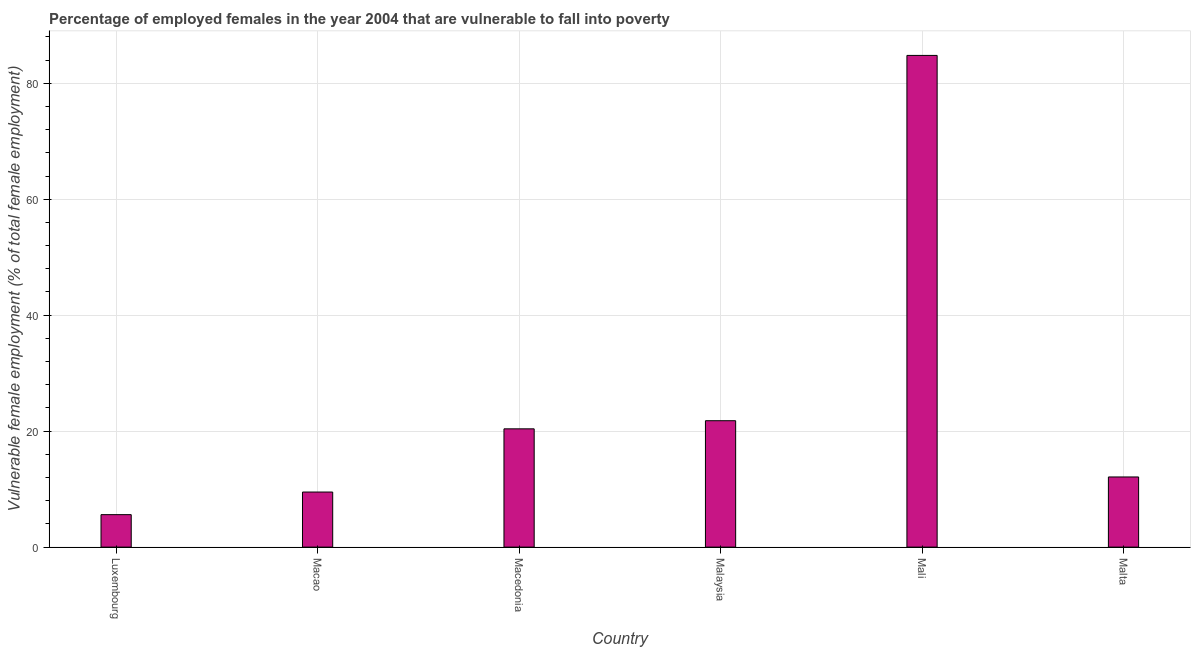Does the graph contain any zero values?
Your response must be concise. No. Does the graph contain grids?
Provide a succinct answer. Yes. What is the title of the graph?
Make the answer very short. Percentage of employed females in the year 2004 that are vulnerable to fall into poverty. What is the label or title of the Y-axis?
Offer a very short reply. Vulnerable female employment (% of total female employment). What is the percentage of employed females who are vulnerable to fall into poverty in Malaysia?
Your answer should be compact. 21.8. Across all countries, what is the maximum percentage of employed females who are vulnerable to fall into poverty?
Offer a very short reply. 84.8. Across all countries, what is the minimum percentage of employed females who are vulnerable to fall into poverty?
Your answer should be compact. 5.6. In which country was the percentage of employed females who are vulnerable to fall into poverty maximum?
Make the answer very short. Mali. In which country was the percentage of employed females who are vulnerable to fall into poverty minimum?
Offer a terse response. Luxembourg. What is the sum of the percentage of employed females who are vulnerable to fall into poverty?
Keep it short and to the point. 154.2. What is the difference between the percentage of employed females who are vulnerable to fall into poverty in Luxembourg and Malaysia?
Offer a very short reply. -16.2. What is the average percentage of employed females who are vulnerable to fall into poverty per country?
Provide a short and direct response. 25.7. What is the median percentage of employed females who are vulnerable to fall into poverty?
Your answer should be very brief. 16.25. What is the ratio of the percentage of employed females who are vulnerable to fall into poverty in Luxembourg to that in Malta?
Provide a succinct answer. 0.46. Is the percentage of employed females who are vulnerable to fall into poverty in Macedonia less than that in Malaysia?
Offer a very short reply. Yes. What is the difference between the highest and the second highest percentage of employed females who are vulnerable to fall into poverty?
Ensure brevity in your answer.  63. What is the difference between the highest and the lowest percentage of employed females who are vulnerable to fall into poverty?
Your answer should be compact. 79.2. In how many countries, is the percentage of employed females who are vulnerable to fall into poverty greater than the average percentage of employed females who are vulnerable to fall into poverty taken over all countries?
Keep it short and to the point. 1. Are all the bars in the graph horizontal?
Your response must be concise. No. Are the values on the major ticks of Y-axis written in scientific E-notation?
Make the answer very short. No. What is the Vulnerable female employment (% of total female employment) of Luxembourg?
Your response must be concise. 5.6. What is the Vulnerable female employment (% of total female employment) of Macedonia?
Your answer should be very brief. 20.4. What is the Vulnerable female employment (% of total female employment) in Malaysia?
Give a very brief answer. 21.8. What is the Vulnerable female employment (% of total female employment) of Mali?
Provide a succinct answer. 84.8. What is the Vulnerable female employment (% of total female employment) of Malta?
Offer a very short reply. 12.1. What is the difference between the Vulnerable female employment (% of total female employment) in Luxembourg and Macao?
Offer a terse response. -3.9. What is the difference between the Vulnerable female employment (% of total female employment) in Luxembourg and Macedonia?
Ensure brevity in your answer.  -14.8. What is the difference between the Vulnerable female employment (% of total female employment) in Luxembourg and Malaysia?
Make the answer very short. -16.2. What is the difference between the Vulnerable female employment (% of total female employment) in Luxembourg and Mali?
Offer a terse response. -79.2. What is the difference between the Vulnerable female employment (% of total female employment) in Macao and Mali?
Ensure brevity in your answer.  -75.3. What is the difference between the Vulnerable female employment (% of total female employment) in Macedonia and Malaysia?
Offer a terse response. -1.4. What is the difference between the Vulnerable female employment (% of total female employment) in Macedonia and Mali?
Your response must be concise. -64.4. What is the difference between the Vulnerable female employment (% of total female employment) in Macedonia and Malta?
Your response must be concise. 8.3. What is the difference between the Vulnerable female employment (% of total female employment) in Malaysia and Mali?
Your response must be concise. -63. What is the difference between the Vulnerable female employment (% of total female employment) in Malaysia and Malta?
Offer a very short reply. 9.7. What is the difference between the Vulnerable female employment (% of total female employment) in Mali and Malta?
Ensure brevity in your answer.  72.7. What is the ratio of the Vulnerable female employment (% of total female employment) in Luxembourg to that in Macao?
Make the answer very short. 0.59. What is the ratio of the Vulnerable female employment (% of total female employment) in Luxembourg to that in Macedonia?
Offer a very short reply. 0.28. What is the ratio of the Vulnerable female employment (% of total female employment) in Luxembourg to that in Malaysia?
Your response must be concise. 0.26. What is the ratio of the Vulnerable female employment (% of total female employment) in Luxembourg to that in Mali?
Provide a short and direct response. 0.07. What is the ratio of the Vulnerable female employment (% of total female employment) in Luxembourg to that in Malta?
Keep it short and to the point. 0.46. What is the ratio of the Vulnerable female employment (% of total female employment) in Macao to that in Macedonia?
Make the answer very short. 0.47. What is the ratio of the Vulnerable female employment (% of total female employment) in Macao to that in Malaysia?
Ensure brevity in your answer.  0.44. What is the ratio of the Vulnerable female employment (% of total female employment) in Macao to that in Mali?
Make the answer very short. 0.11. What is the ratio of the Vulnerable female employment (% of total female employment) in Macao to that in Malta?
Offer a terse response. 0.79. What is the ratio of the Vulnerable female employment (% of total female employment) in Macedonia to that in Malaysia?
Make the answer very short. 0.94. What is the ratio of the Vulnerable female employment (% of total female employment) in Macedonia to that in Mali?
Your response must be concise. 0.24. What is the ratio of the Vulnerable female employment (% of total female employment) in Macedonia to that in Malta?
Make the answer very short. 1.69. What is the ratio of the Vulnerable female employment (% of total female employment) in Malaysia to that in Mali?
Your response must be concise. 0.26. What is the ratio of the Vulnerable female employment (% of total female employment) in Malaysia to that in Malta?
Ensure brevity in your answer.  1.8. What is the ratio of the Vulnerable female employment (% of total female employment) in Mali to that in Malta?
Make the answer very short. 7.01. 